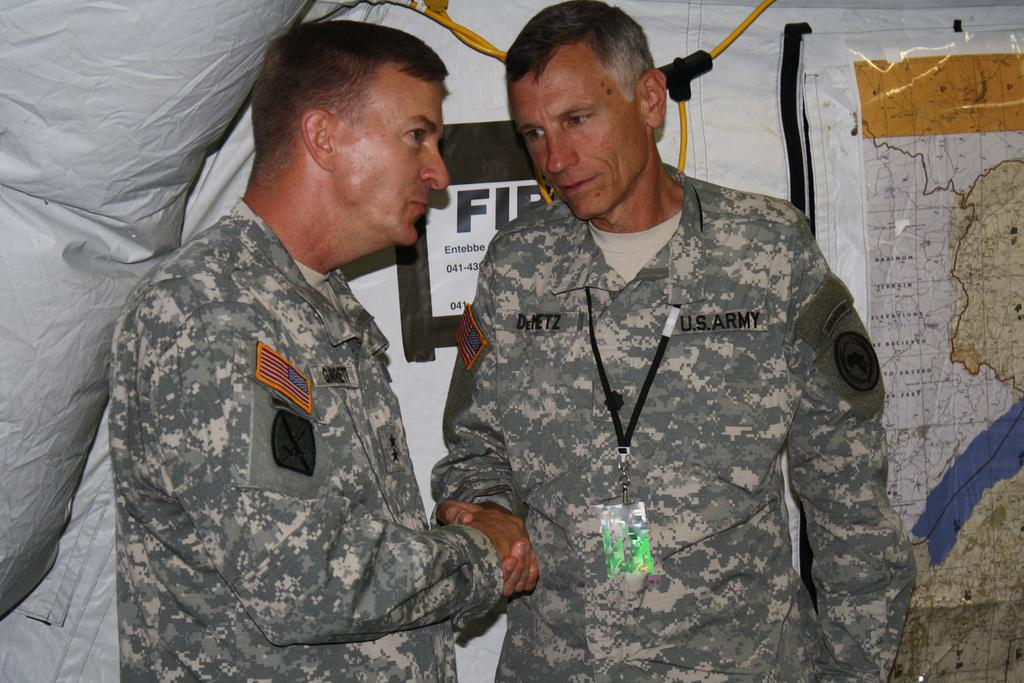How many people are in the image? There are two men standing in the center of the image. What can be seen in the background of the image? There is a banner, a wire, and a poster in the background of the image. Are the two men in the image sisters? No, the two men in the image are not sisters; they are men. What type of floor can be seen in the image? There is no information about the floor in the image, as the focus is on the two men and the background elements. 